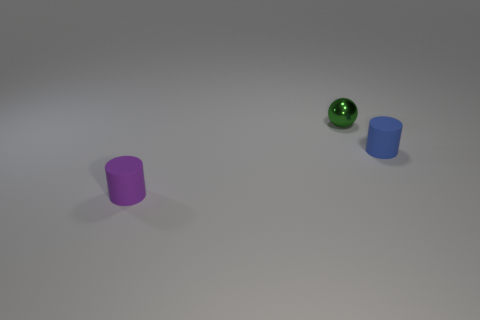Add 1 green spheres. How many objects exist? 4 Subtract all spheres. How many objects are left? 2 Add 1 tiny green spheres. How many tiny green spheres exist? 2 Subtract 0 brown cubes. How many objects are left? 3 Subtract all yellow metal cylinders. Subtract all green metal spheres. How many objects are left? 2 Add 1 tiny green spheres. How many tiny green spheres are left? 2 